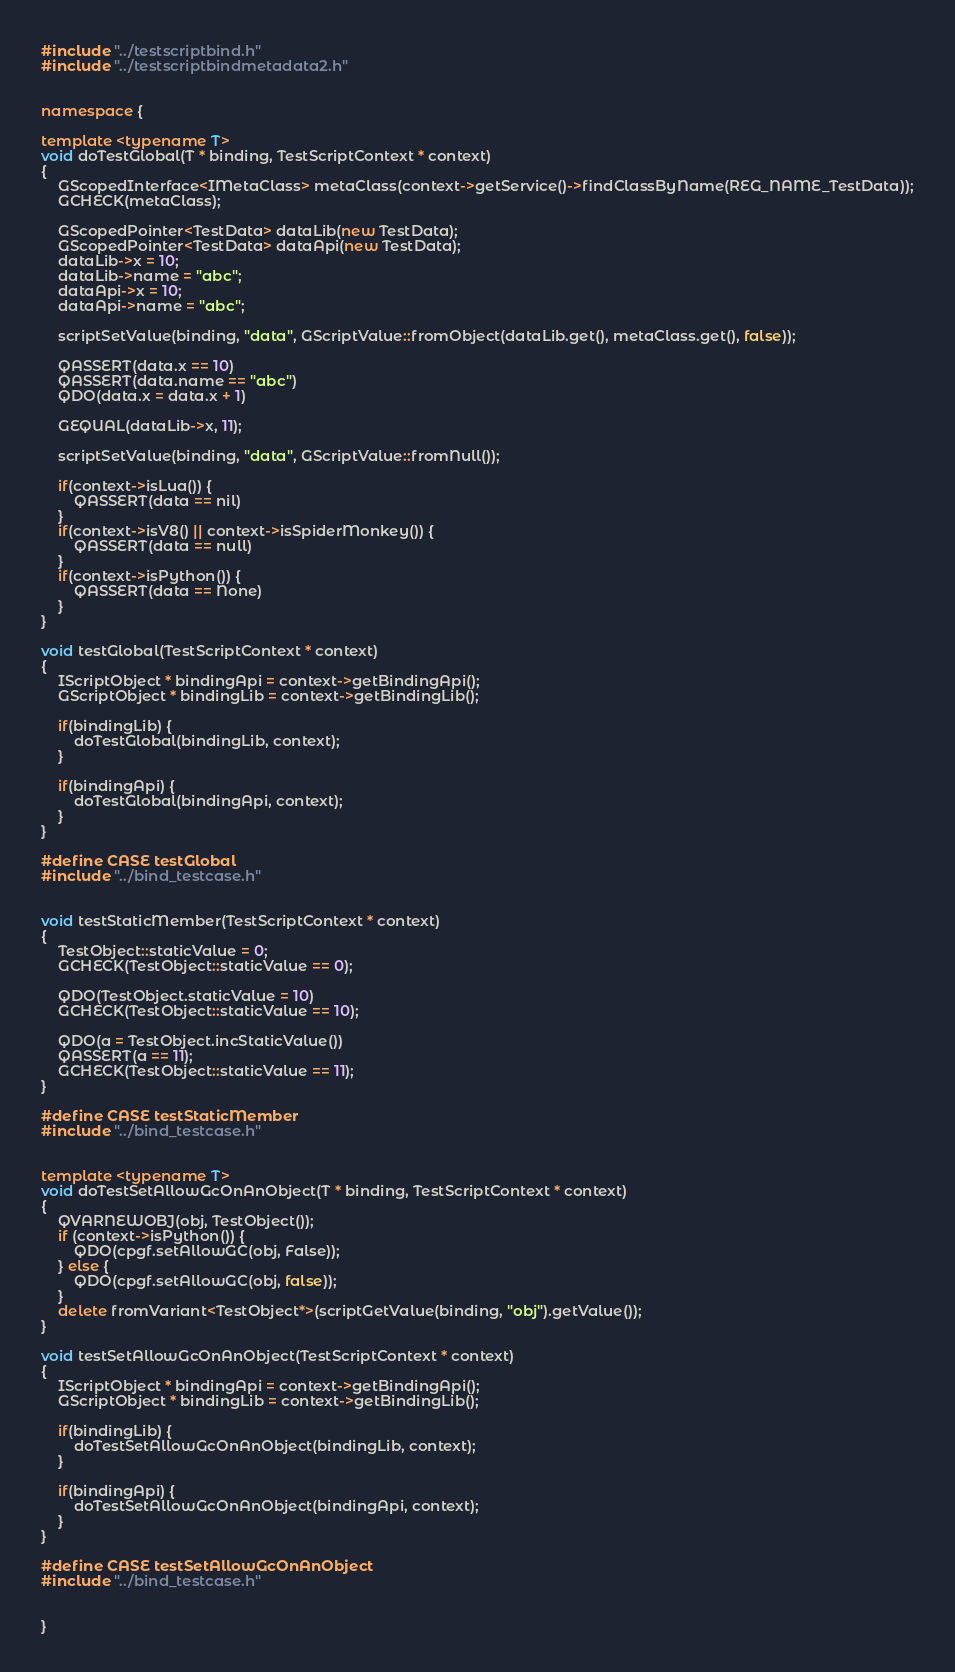<code> <loc_0><loc_0><loc_500><loc_500><_C++_>#include "../testscriptbind.h"
#include "../testscriptbindmetadata2.h"


namespace {

template <typename T>
void doTestGlobal(T * binding, TestScriptContext * context)
{
	GScopedInterface<IMetaClass> metaClass(context->getService()->findClassByName(REG_NAME_TestData));
	GCHECK(metaClass);

	GScopedPointer<TestData> dataLib(new TestData);
	GScopedPointer<TestData> dataApi(new TestData);
	dataLib->x = 10;
	dataLib->name = "abc";
	dataApi->x = 10;
	dataApi->name = "abc";

	scriptSetValue(binding, "data", GScriptValue::fromObject(dataLib.get(), metaClass.get(), false));

	QASSERT(data.x == 10)
	QASSERT(data.name == "abc")
	QDO(data.x = data.x + 1)

	GEQUAL(dataLib->x, 11);

	scriptSetValue(binding, "data", GScriptValue::fromNull());

	if(context->isLua()) {
		QASSERT(data == nil)
	}
	if(context->isV8() || context->isSpiderMonkey()) {
		QASSERT(data == null)
	}
	if(context->isPython()) {
		QASSERT(data == None)
	}
}

void testGlobal(TestScriptContext * context)
{
	IScriptObject * bindingApi = context->getBindingApi();
	GScriptObject * bindingLib = context->getBindingLib();

	if(bindingLib) {
		doTestGlobal(bindingLib, context);
	}

	if(bindingApi) {
		doTestGlobal(bindingApi, context);
	}
}

#define CASE testGlobal
#include "../bind_testcase.h"


void testStaticMember(TestScriptContext * context)
{
	TestObject::staticValue = 0;
	GCHECK(TestObject::staticValue == 0);

	QDO(TestObject.staticValue = 10)
	GCHECK(TestObject::staticValue == 10);

	QDO(a = TestObject.incStaticValue())
	QASSERT(a == 11);
	GCHECK(TestObject::staticValue == 11);
}

#define CASE testStaticMember
#include "../bind_testcase.h"


template <typename T>
void doTestSetAllowGcOnAnObject(T * binding, TestScriptContext * context)
{
	QVARNEWOBJ(obj, TestObject());
	if (context->isPython()) {
		QDO(cpgf.setAllowGC(obj, False));
	} else {
		QDO(cpgf.setAllowGC(obj, false));
	}
	delete fromVariant<TestObject*>(scriptGetValue(binding, "obj").getValue());
}

void testSetAllowGcOnAnObject(TestScriptContext * context)
{
	IScriptObject * bindingApi = context->getBindingApi();
	GScriptObject * bindingLib = context->getBindingLib();

	if(bindingLib) {
		doTestSetAllowGcOnAnObject(bindingLib, context);
	}

	if(bindingApi) {
		doTestSetAllowGcOnAnObject(bindingApi, context);
	}
}

#define CASE testSetAllowGcOnAnObject
#include "../bind_testcase.h"


}
</code> 